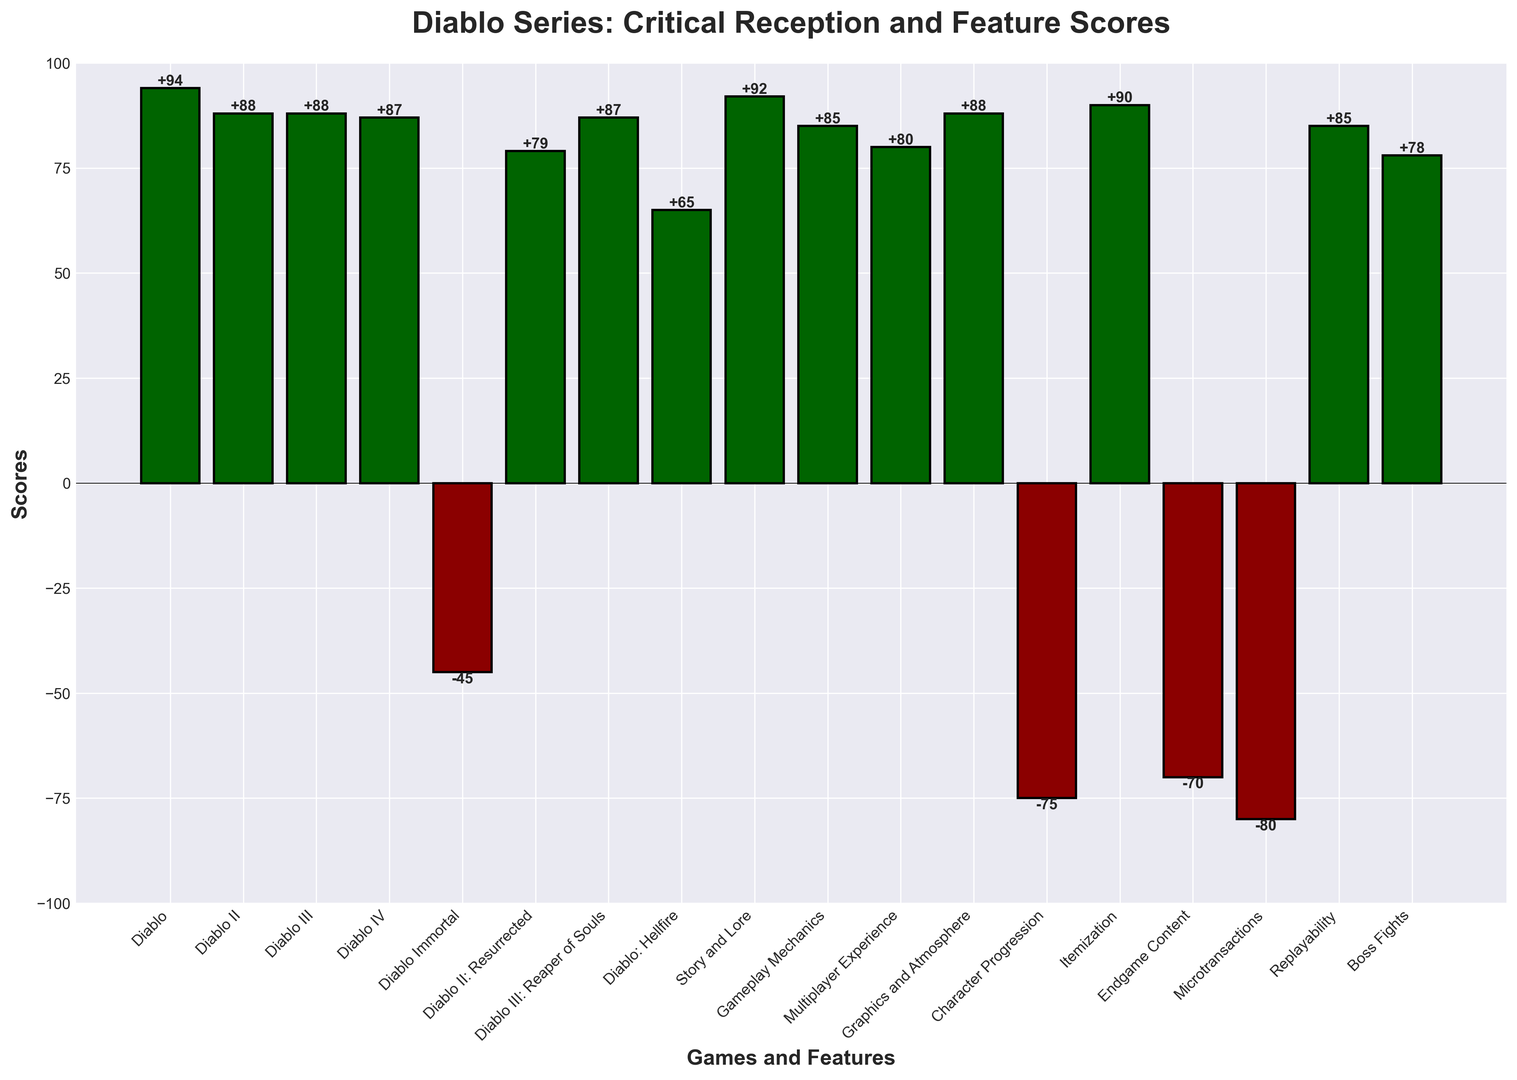What's the highest-rated game or feature in the Diablo series? To identify the highest-rated game or feature, we look for the bar with the greatest positive height. The highest bar corresponds to the "Story and Lore" with a score of +92.
Answer: Story and Lore Which game or feature has the most negative reception? To find the game or feature with the most negative reception, we look for the bar with the lowest negative height. The bar for "Microtransactions" has the lowest score at -80.
Answer: Microtransactions How do Diablo II and Diablo III compare in terms of their scores? By comparing the heights of the bars for Diablo II and Diablo III, both scores are 88, indicating they have equal reception scores.
Answer: Equal What are the total scores of positive features (features with positive scores)? Adding the positive scores of Story and Lore (92), Gameplay Mechanics (85), Multiplayer Experience (80), Graphics and Atmosphere (88), Itemization (90), Replayability (85), and Boss Fights (78), we get 92 + 85 + 80 + 88 + 90 + 85 + 78 = 598.
Answer: 598 Which game has the closest score to Diablo IV? To find the closest score to Diablo IV’s score of 87, we look at the other scores. Diablo III: Reaper of Souls has the same score of 87.
Answer: Diablo III: Reaper of Souls How much lower is the Endgame Content score compared to the Story and Lore score? The Endgame Content score is -70 and the Story and Lore score is 92. The difference is 92 - (-70) = 92 + 70 = 162.
Answer: 162 What is the median score of games in the Diablo series? Sorting the game scores: -45, 65, 79, 87, 87, 88, 88, 94. There are 8 scores, so the median is the average of the 4th and 5th values: (87 + 87) / 2 = 87.
Answer: 87 Which has a higher score, Diablo II: Resurrected or Diablo: Hellfire? By comparing the heights of their respective bars, Diablo II: Resurrected has a score of 79 which is higher than Diablo: Hellfire’s score of 65.
Answer: Diablo II: Resurrected What is the average score of negative features? Adding the negative scores of Character Progression (-75), Endgame Content (-70), and Microtransactions (-80), we get -75 + (-70) + (-80) = -225. Dividing by the number of features, the average = -225 / 3 = -75.
Answer: -75 